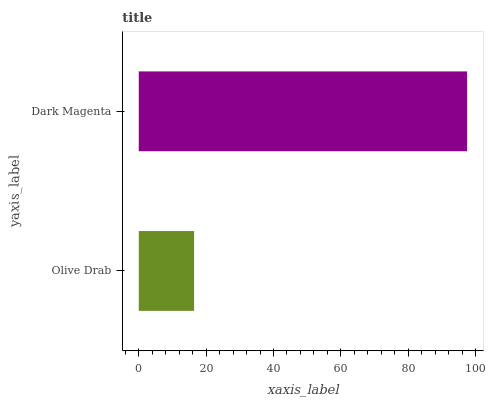Is Olive Drab the minimum?
Answer yes or no. Yes. Is Dark Magenta the maximum?
Answer yes or no. Yes. Is Dark Magenta the minimum?
Answer yes or no. No. Is Dark Magenta greater than Olive Drab?
Answer yes or no. Yes. Is Olive Drab less than Dark Magenta?
Answer yes or no. Yes. Is Olive Drab greater than Dark Magenta?
Answer yes or no. No. Is Dark Magenta less than Olive Drab?
Answer yes or no. No. Is Dark Magenta the high median?
Answer yes or no. Yes. Is Olive Drab the low median?
Answer yes or no. Yes. Is Olive Drab the high median?
Answer yes or no. No. Is Dark Magenta the low median?
Answer yes or no. No. 